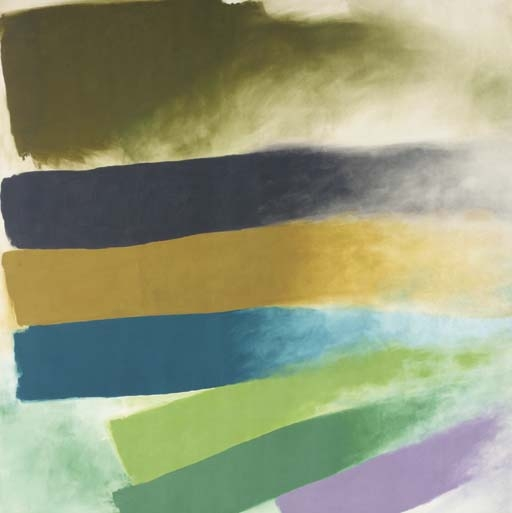Describe the following image. The painting is an evocative piece of modern abstract expressionism, showcasing an array of horizontal color bands that sweep across the canvas in a fluid yet defined manner. The colors—deep green, navy blue, golden yellow, bright aqua, and muted lavender—are layered against a subtle greenish backdrop. Each stroke of color maintains a soft, blended boundary, giving the illusion of depth and movement. This artwork could evoke different emotions, suggesting themes of serenity or dynamic change, depending on the viewer's perspective. 